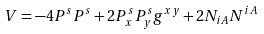Convert formula to latex. <formula><loc_0><loc_0><loc_500><loc_500>V = - 4 P ^ { s } P ^ { s } + 2 P _ { x } ^ { s } P _ { y } ^ { s } g ^ { x y } + 2 N _ { i A } N ^ { i A }</formula> 